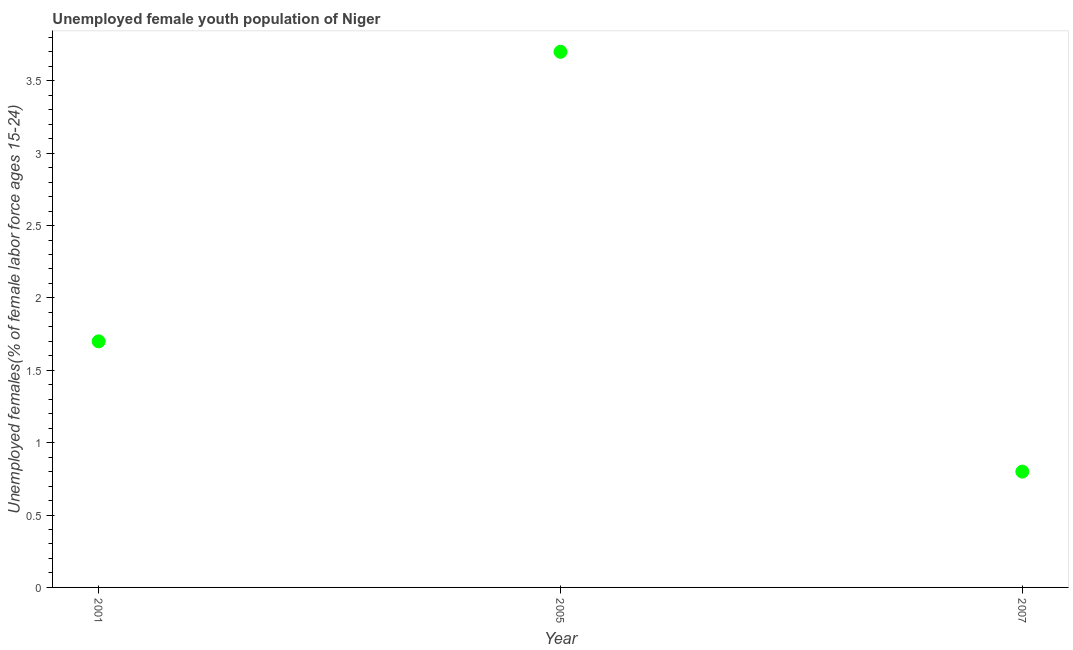What is the unemployed female youth in 2007?
Your answer should be compact. 0.8. Across all years, what is the maximum unemployed female youth?
Ensure brevity in your answer.  3.7. Across all years, what is the minimum unemployed female youth?
Offer a very short reply. 0.8. What is the sum of the unemployed female youth?
Your response must be concise. 6.2. What is the difference between the unemployed female youth in 2005 and 2007?
Provide a succinct answer. 2.9. What is the average unemployed female youth per year?
Your response must be concise. 2.07. What is the median unemployed female youth?
Keep it short and to the point. 1.7. In how many years, is the unemployed female youth greater than 3.7 %?
Your answer should be very brief. 1. Do a majority of the years between 2001 and 2007 (inclusive) have unemployed female youth greater than 3.4 %?
Give a very brief answer. No. What is the ratio of the unemployed female youth in 2005 to that in 2007?
Offer a terse response. 4.62. Is the unemployed female youth in 2001 less than that in 2005?
Ensure brevity in your answer.  Yes. What is the difference between the highest and the second highest unemployed female youth?
Your answer should be compact. 2. Is the sum of the unemployed female youth in 2001 and 2007 greater than the maximum unemployed female youth across all years?
Make the answer very short. No. What is the difference between the highest and the lowest unemployed female youth?
Your answer should be very brief. 2.9. In how many years, is the unemployed female youth greater than the average unemployed female youth taken over all years?
Offer a very short reply. 1. What is the difference between two consecutive major ticks on the Y-axis?
Keep it short and to the point. 0.5. Are the values on the major ticks of Y-axis written in scientific E-notation?
Give a very brief answer. No. What is the title of the graph?
Your answer should be compact. Unemployed female youth population of Niger. What is the label or title of the Y-axis?
Provide a succinct answer. Unemployed females(% of female labor force ages 15-24). What is the Unemployed females(% of female labor force ages 15-24) in 2001?
Offer a terse response. 1.7. What is the Unemployed females(% of female labor force ages 15-24) in 2005?
Offer a very short reply. 3.7. What is the Unemployed females(% of female labor force ages 15-24) in 2007?
Your response must be concise. 0.8. What is the difference between the Unemployed females(% of female labor force ages 15-24) in 2001 and 2005?
Your answer should be very brief. -2. What is the difference between the Unemployed females(% of female labor force ages 15-24) in 2005 and 2007?
Your response must be concise. 2.9. What is the ratio of the Unemployed females(% of female labor force ages 15-24) in 2001 to that in 2005?
Make the answer very short. 0.46. What is the ratio of the Unemployed females(% of female labor force ages 15-24) in 2001 to that in 2007?
Your response must be concise. 2.12. What is the ratio of the Unemployed females(% of female labor force ages 15-24) in 2005 to that in 2007?
Your response must be concise. 4.62. 